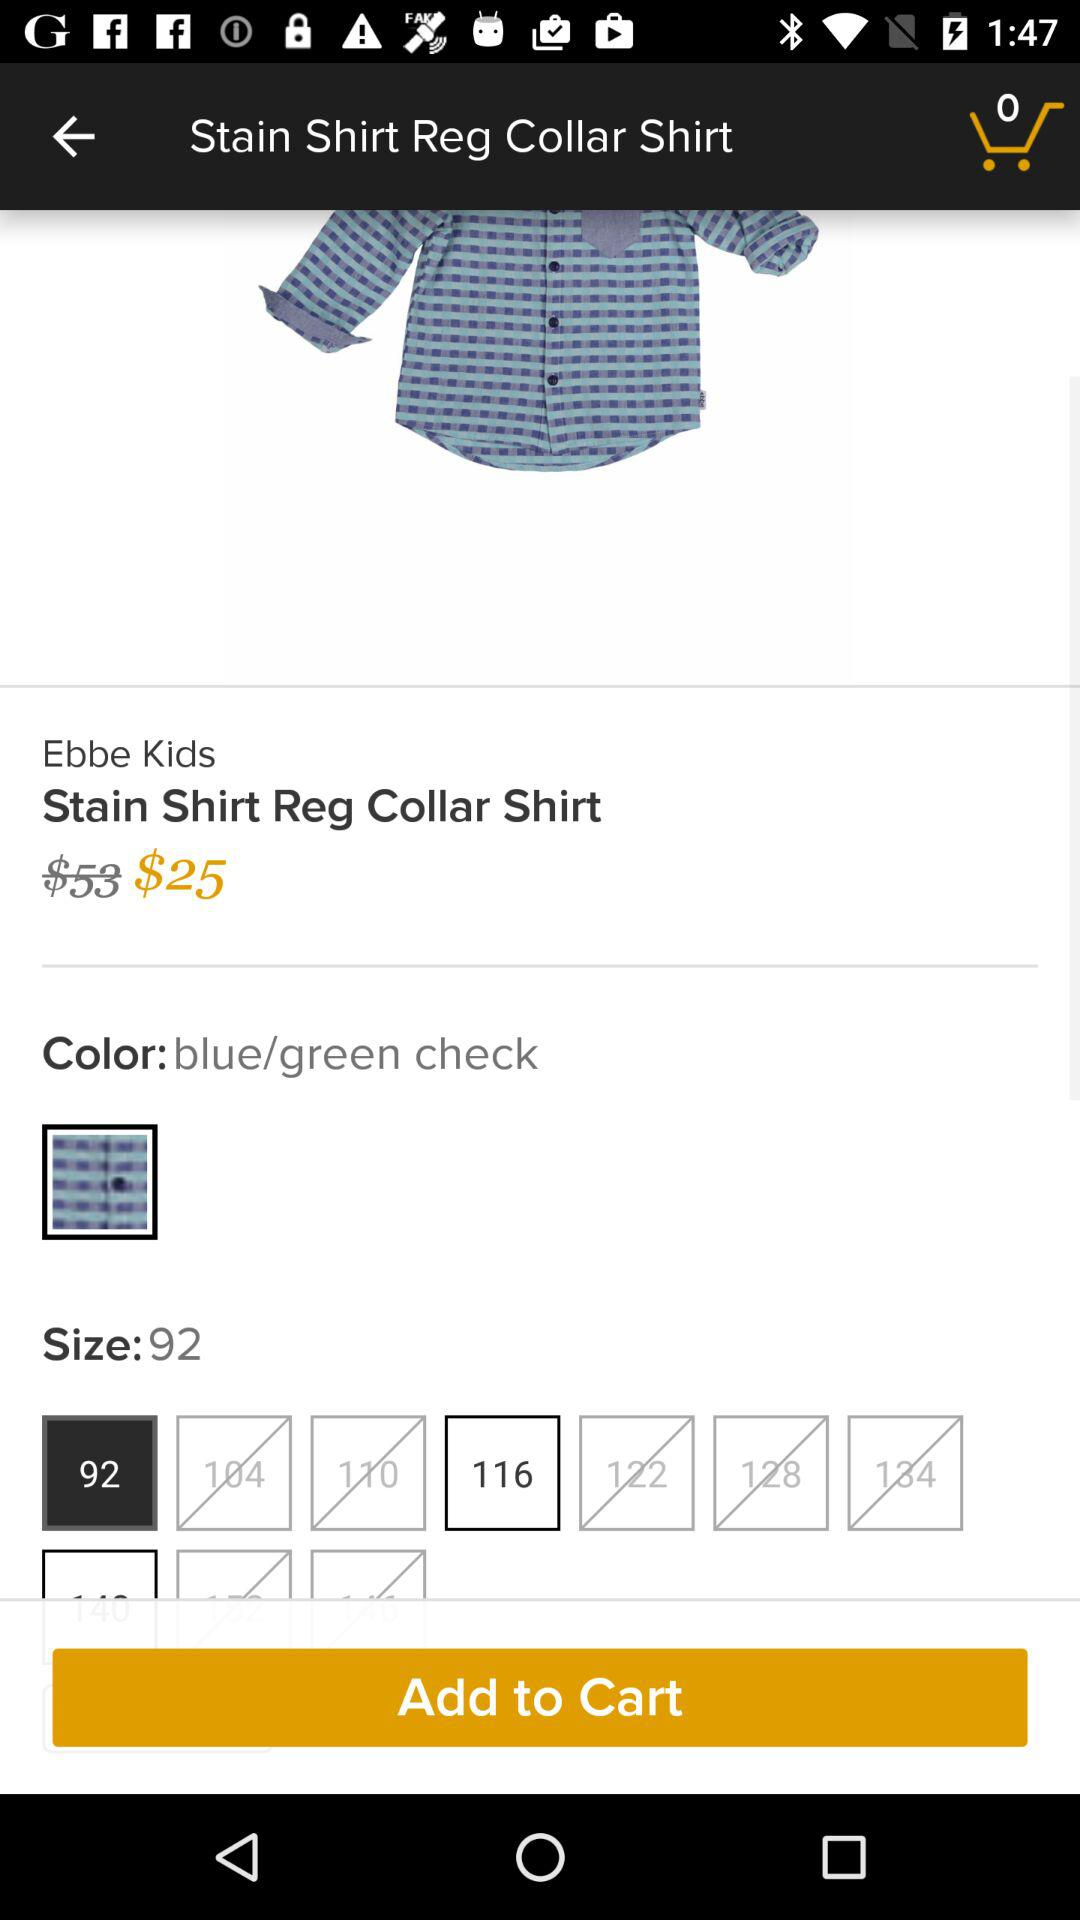What is the price of a "Stain Shirt Reg Collar Shirt"? The price is $25. 